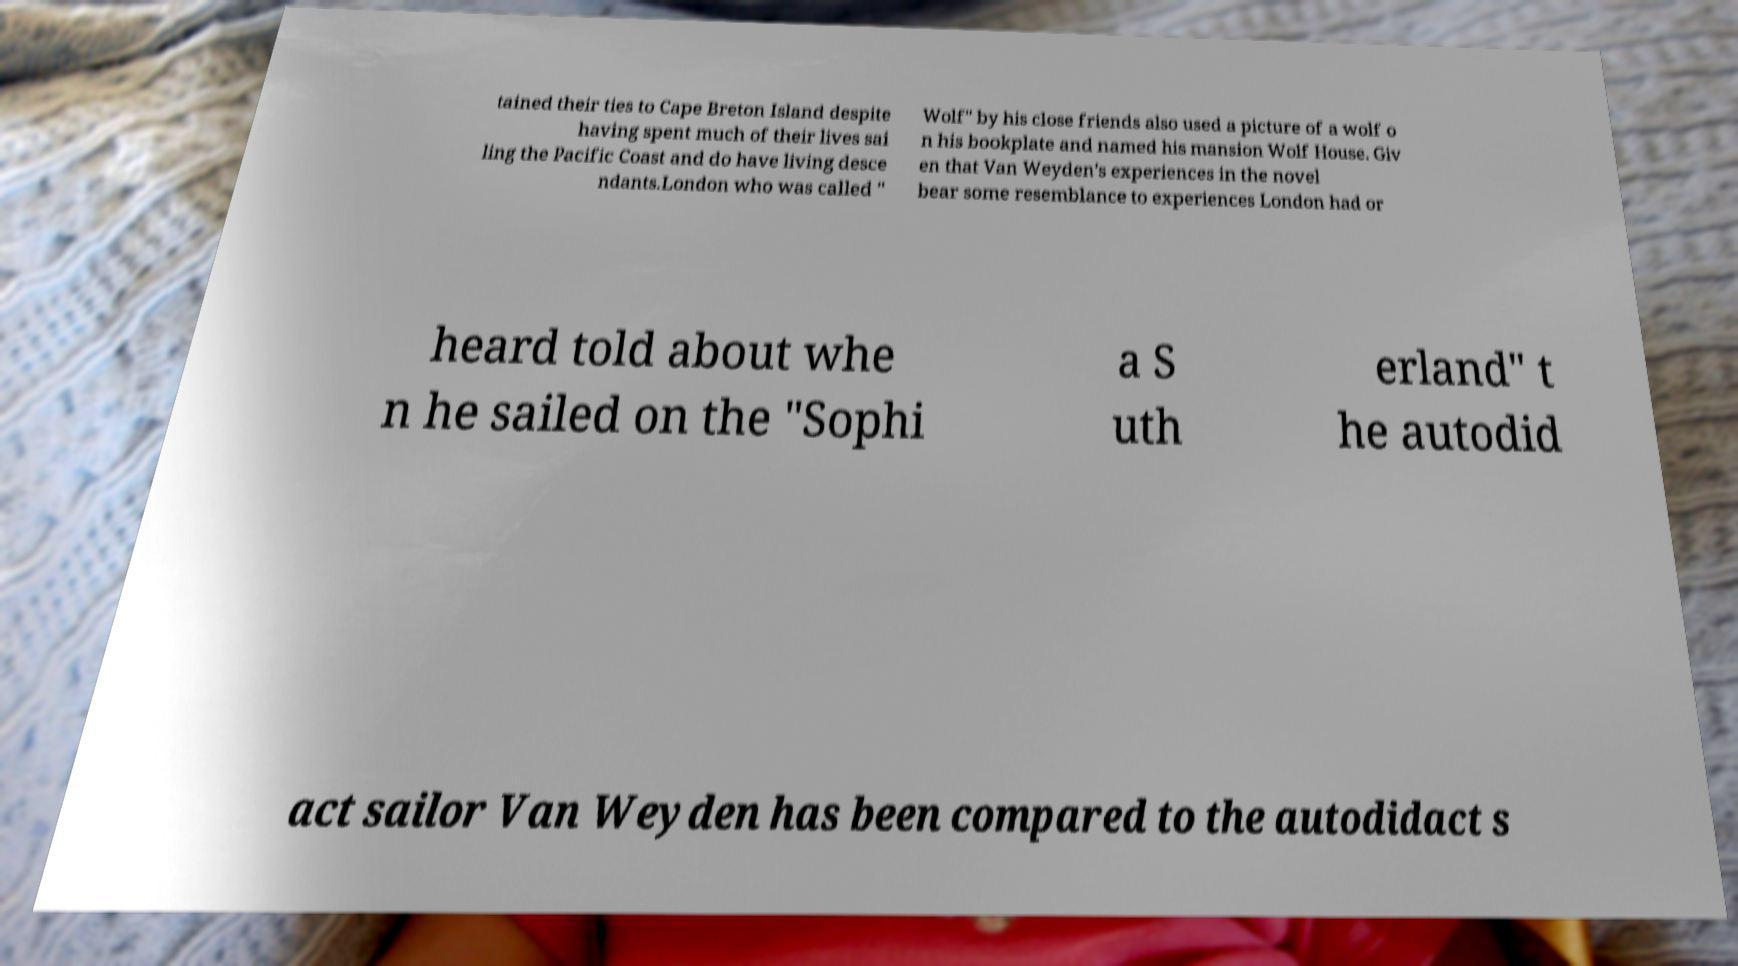Could you assist in decoding the text presented in this image and type it out clearly? tained their ties to Cape Breton Island despite having spent much of their lives sai ling the Pacific Coast and do have living desce ndants.London who was called " Wolf" by his close friends also used a picture of a wolf o n his bookplate and named his mansion Wolf House. Giv en that Van Weyden's experiences in the novel bear some resemblance to experiences London had or heard told about whe n he sailed on the "Sophi a S uth erland" t he autodid act sailor Van Weyden has been compared to the autodidact s 